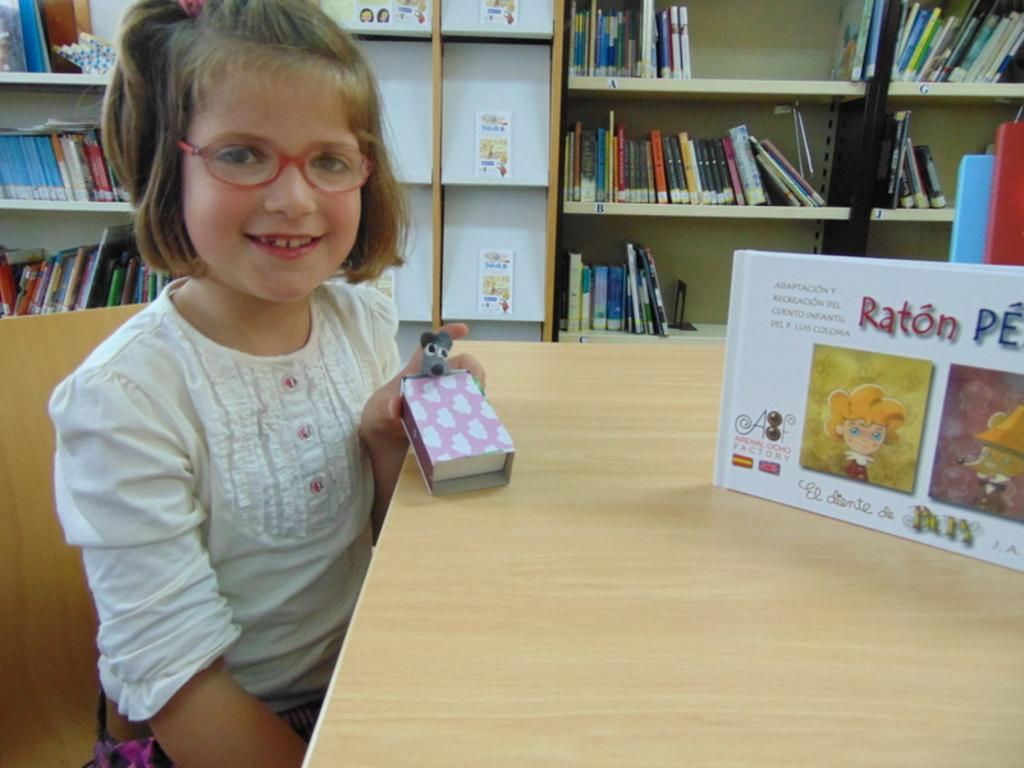<image>
Describe the image concisely. A little girl is sitting at a table that has the book Raton sitting on it. 